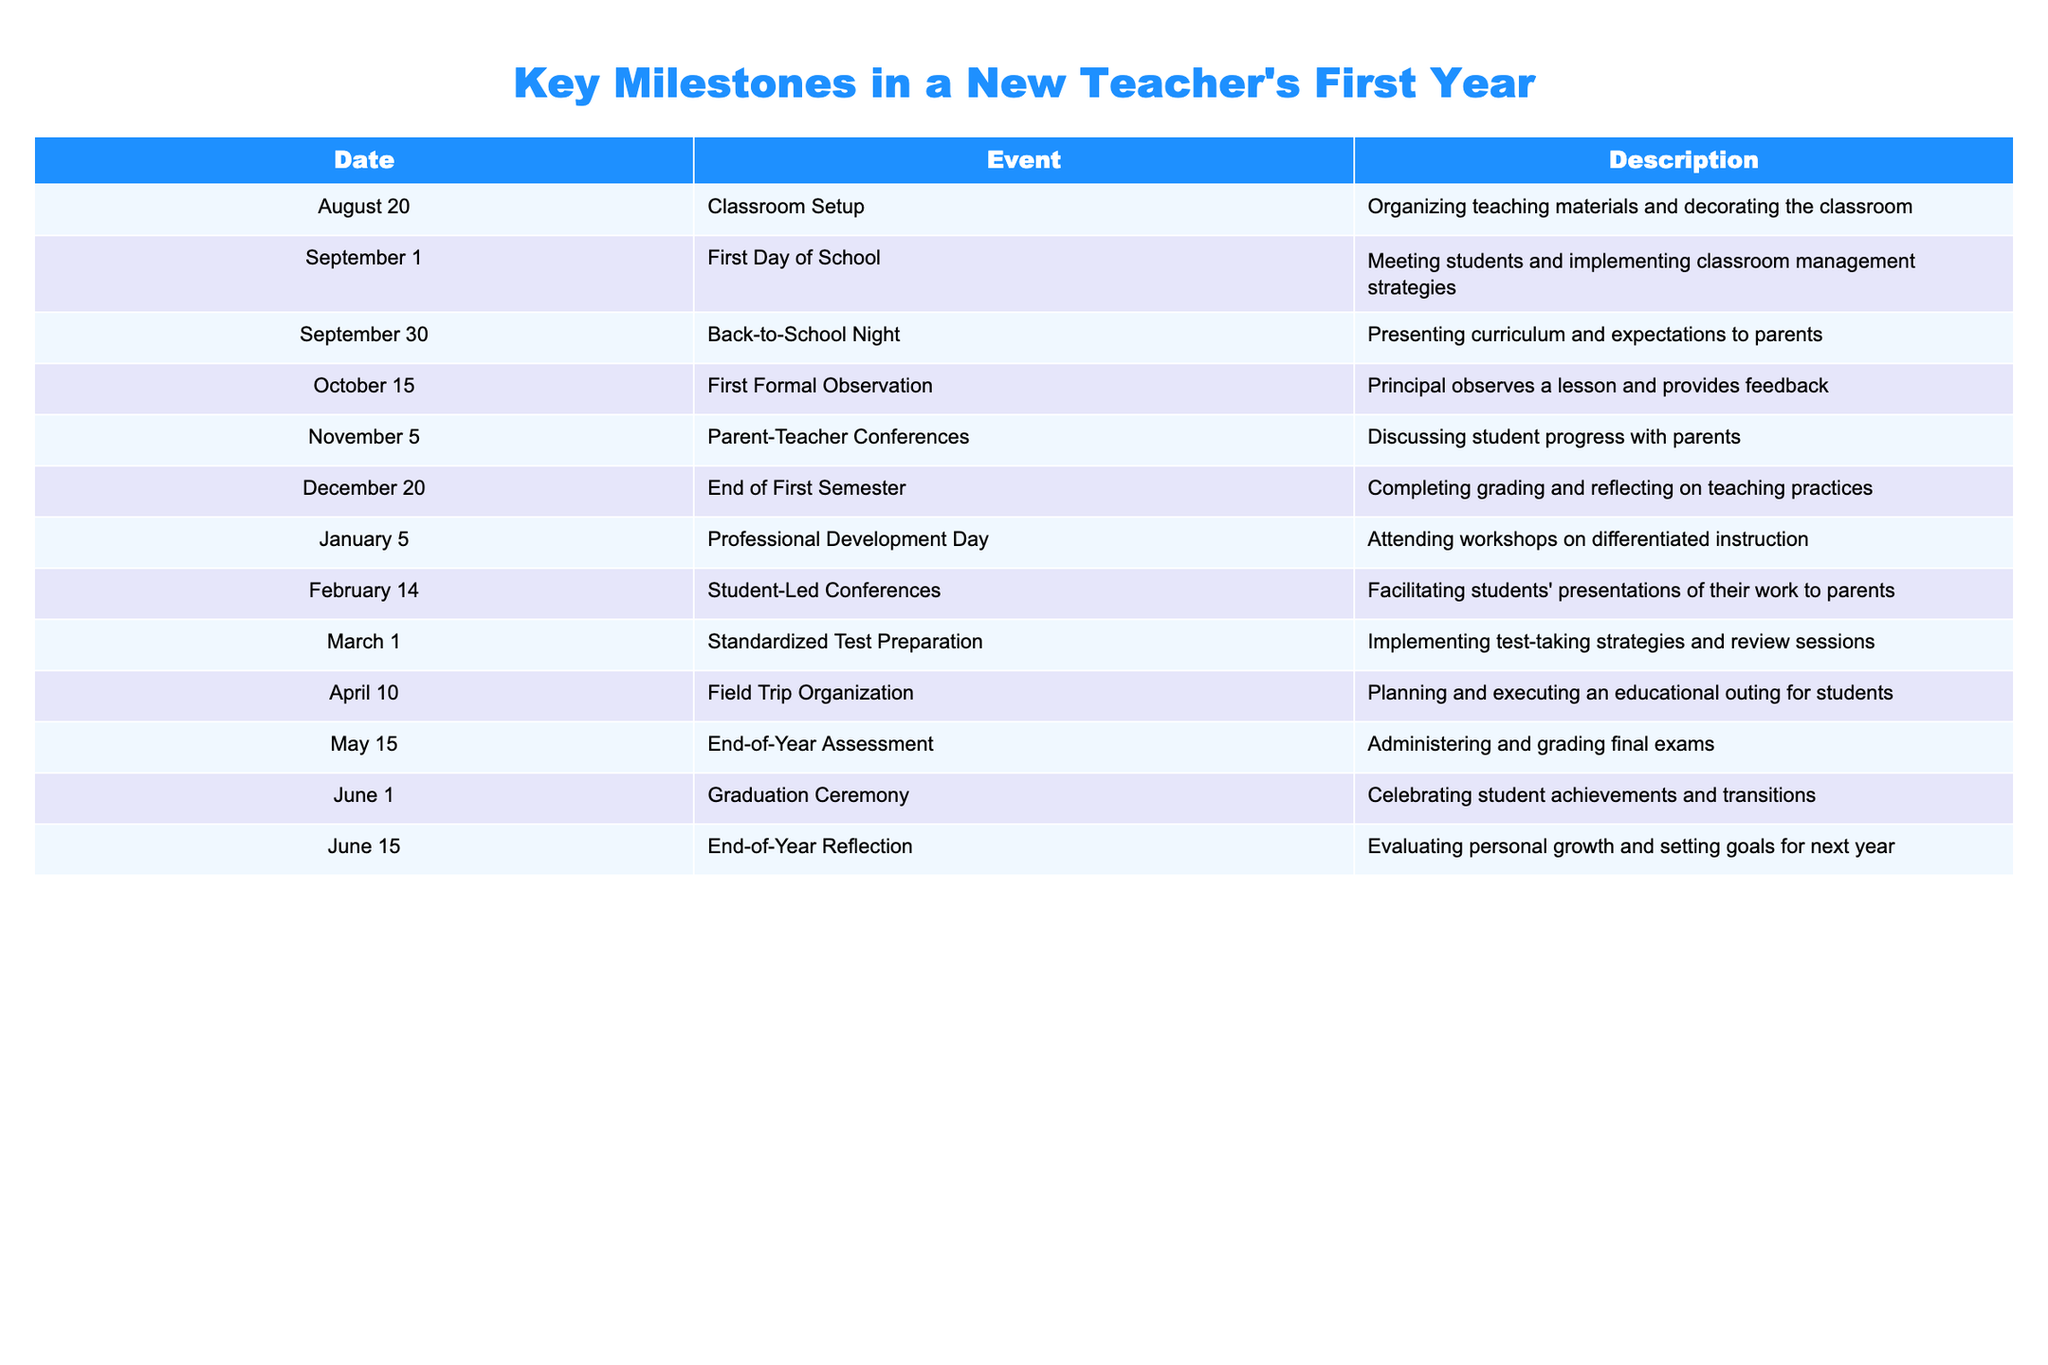What event occurs on October 15? According to the table, October 15 is marked as the date for the "First Formal Observation," which indicates that the principal observes a lesson and provides feedback.
Answer: First Formal Observation Which event takes place just before the End of the First Semester? The table shows that the Parent-Teacher Conferences on November 5 occur before the End of the First Semester, which is on December 20. So, November 5 is the event that takes place just before December 20.
Answer: Parent-Teacher Conferences How many events are scheduled between the First Day of School and the End of the First Semester? There are three events between the First Day of School (September 1) and the End of the First Semester (December 20): Back-to-School Night (September 30), First Formal Observation (October 15), and Parent-Teacher Conferences (November 5). This gives us a total of 3 events.
Answer: 3 Did the teacher have professional development training before the End of Year Assessment? The table indicates that the Professional Development Day, where the teacher attends workshops, is on January 5. The End-of-Year Assessment occurs on May 15. Since January is before May, the teacher did indeed have professional development training before the End-of-Year Assessment.
Answer: Yes Identify the two events that involve parents and their students. The two events that involve parents and their students are the Back-to-School Night on September 30, where the teacher presents curriculum and expectations to parents, and the Student-Led Conferences on February 14, where students present their work to parents.
Answer: Back-to-School Night and Student-Led Conferences Calculate the time span between the First Day of School and the Graduation Ceremony. The First Day of School is on September 1 and the Graduation Ceremony occurs on June 1 of the following year. Counting the months in between, we have: September (30 days), October (31 days), November (30 days), December (31 days), January (31 days), February (28 days), March (31 days), April (30 days), May (31 days), and finally June 1. Therefore, the total time span is approximately 9 months.
Answer: 9 months What is the last event listed in the table? The last event in the table is the "End-of-Year Reflection" on June 15. This is the concluding milestone for the new teacher in their first year.
Answer: End-of-Year Reflection Was there any event related to standardized testing, and if so, when did it occur? Yes, there is an event related to standardized testing, which is "Standardized Test Preparation" taking place on March 1. This indicates a focused effort on preparing for standardized assessments during that time.
Answer: Yes, on March 1 